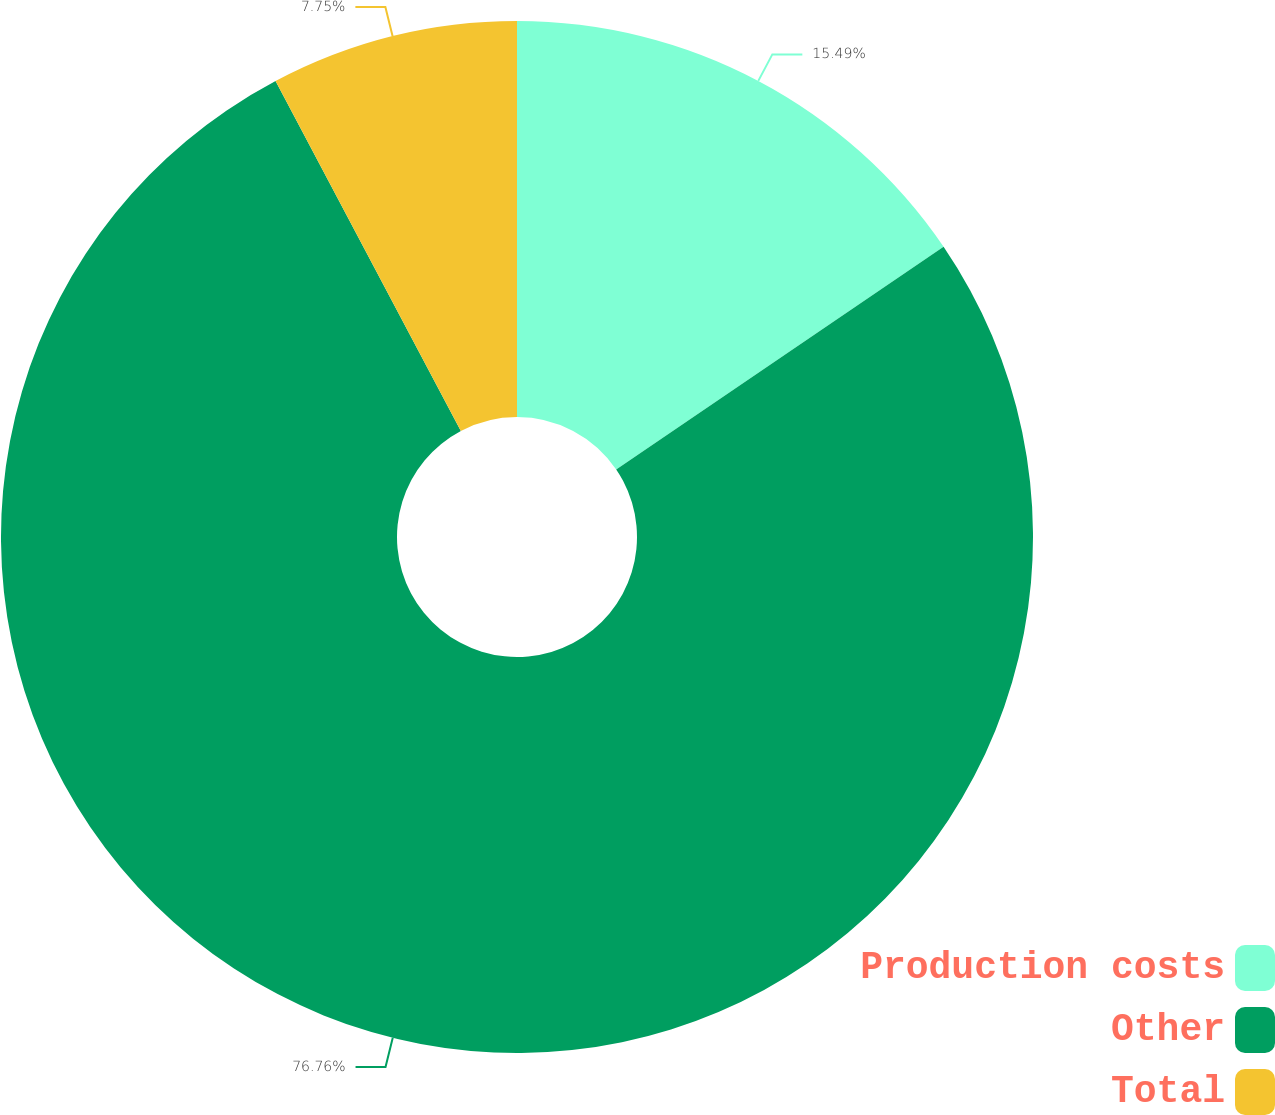Convert chart. <chart><loc_0><loc_0><loc_500><loc_500><pie_chart><fcel>Production costs<fcel>Other<fcel>Total<nl><fcel>15.49%<fcel>76.76%<fcel>7.75%<nl></chart> 